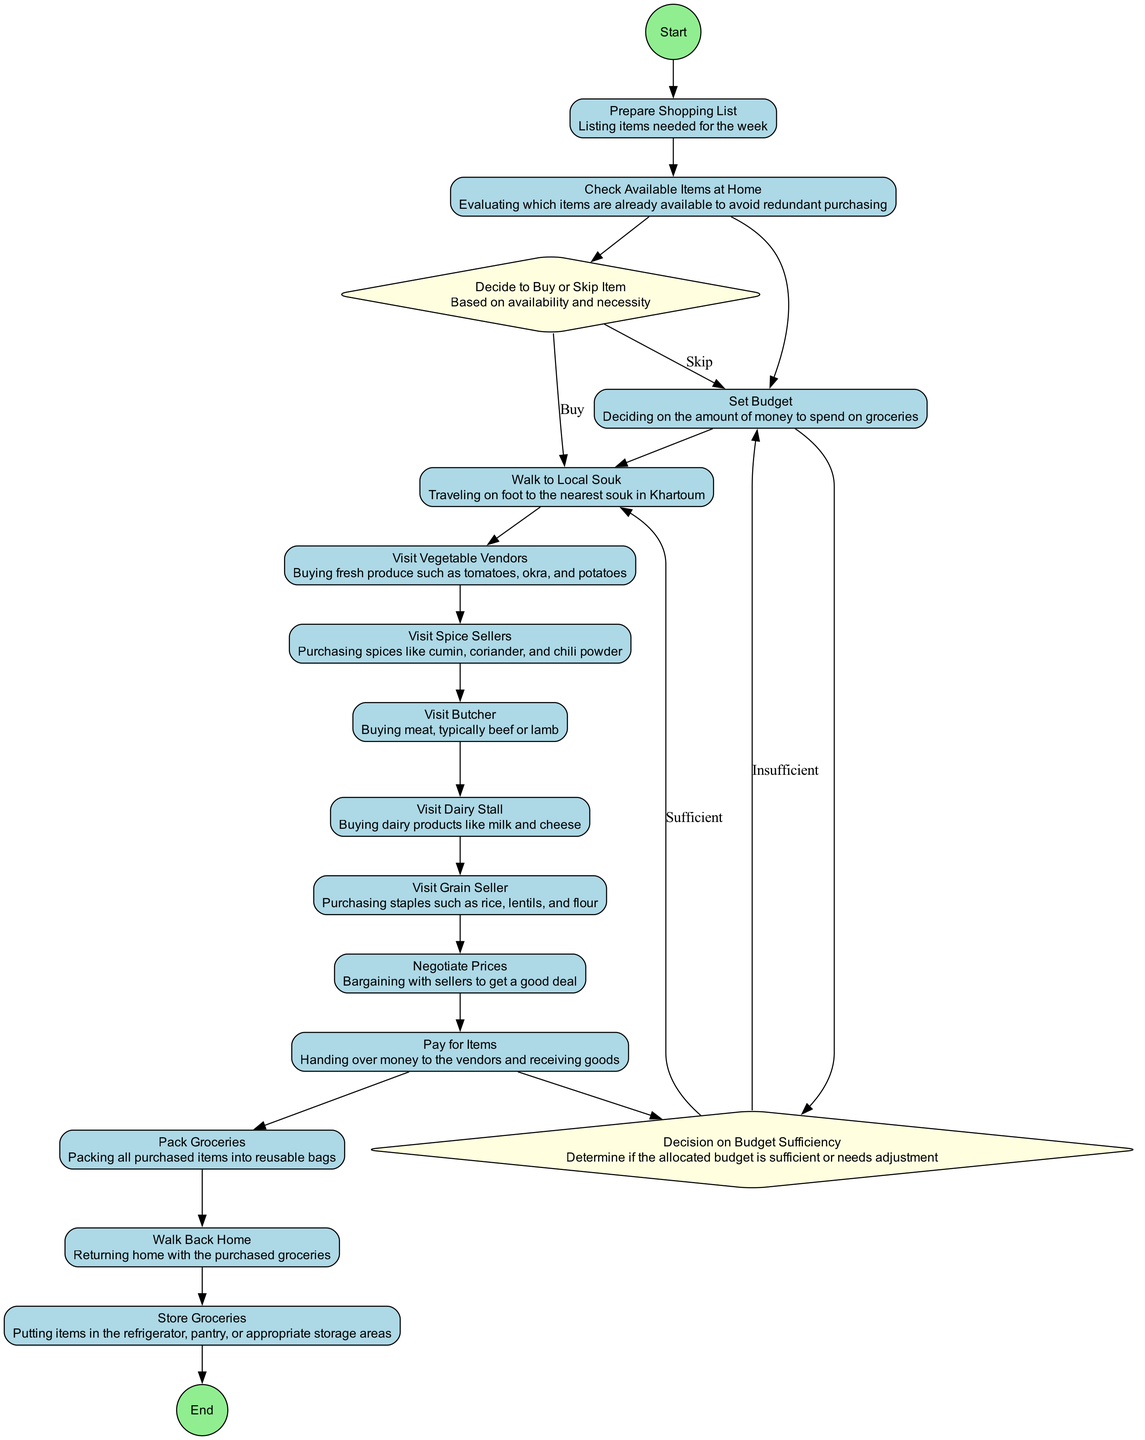What is the first activity in the diagram? The diagram starts with the 'Prepare Shopping List' node, indicating it is the first step in the sequence for grocery shopping.
Answer: Prepare Shopping List How many decision nodes are present in the diagram? The diagram contains two decision nodes: 'Decide to Buy or Skip Item' and 'Decision on Budget Sufficiency'.
Answer: 2 What activity comes after 'Visit Grain Seller'? The activity that directly follows 'Visit Grain Seller' is 'Negotiate Prices', indicating that bargaining occurs after purchasing grains.
Answer: Negotiate Prices Which node does 'Walk to Local Souk' connect to after 'Set Budget'? After 'Set Budget', 'Walk to Local Souk' is the next connected activity, showing that walking to the souk occurs following budget allocation.
Answer: Walk to Local Souk What happens if the budget is insufficient? If the budget is determined insufficient, the path proceeds back to 'Set Budget', indicating the need to adjust the budget before moving forward.
Answer: Set Budget Which activity requires visiting multiple vendors in the local souk? The activities 'Visit Vegetable Vendors', 'Visit Spice Sellers', 'Visit Butcher', 'Visit Dairy Stall', and 'Visit Grain Seller' all involve visiting different vendors in the souk for grocery shopping.
Answer: All specified vendors What is the final activity in the diagram before returning home? The last activity in the sequence before the end is 'Store Groceries', indicating that the groceries are stored after returning home.
Answer: Store Groceries What decision must be made regarding the necessity of items? The decision 'Decide to Buy or Skip Item' must be made based on the evaluation of item necessity and availability at home.
Answer: Decide to Buy or Skip Item What indicates a successful purchase in the souk? The 'Pay for Items' activity indicates a successful purchase as money is handed over to vendors in exchange for goods.
Answer: Pay for Items 